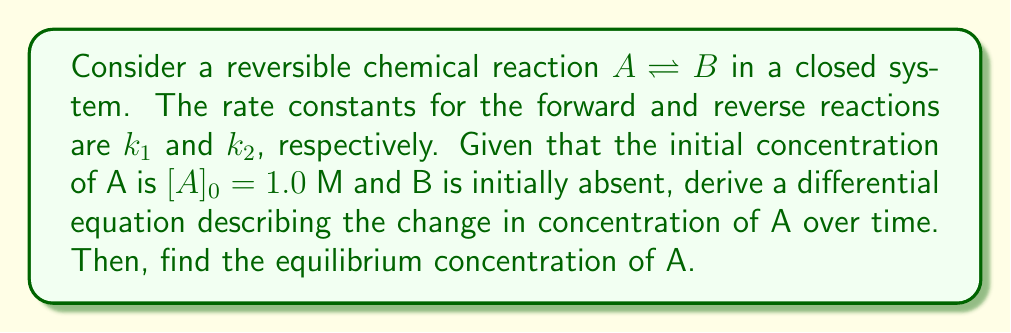Can you solve this math problem? 1) First, let's set up the rate equation for the change in concentration of A:

   $$\frac{d[A]}{dt} = -k_1[A] + k_2[B]$$

2) We know that in a closed system, the total concentration remains constant:

   $$[A] + [B] = [A]_0 = 1.0 \text{ M}$$

3) Substituting $[B] = 1.0 - [A]$ into the rate equation:

   $$\frac{d[A]}{dt} = -k_1[A] + k_2(1.0 - [A]) = k_2 - (k_1 + k_2)[A]$$

4) At equilibrium, the concentration doesn't change, so $\frac{d[A]}{dt} = 0$:

   $$0 = k_2 - (k_1 + k_2)[A]_{eq}$$

5) Solving for $[A]_{eq}$:

   $$[A]_{eq} = \frac{k_2}{k_1 + k_2}$$

6) This can also be written in terms of the equilibrium constant $K_{eq} = \frac{k_1}{k_2}$:

   $$[A]_{eq} = \frac{1}{1 + K_{eq}}$$

Thus, we've derived the differential equation and found the equilibrium concentration of A in terms of the rate constants or the equilibrium constant.
Answer: $[A]_{eq} = \frac{k_2}{k_1 + k_2} = \frac{1}{1 + K_{eq}}$ 